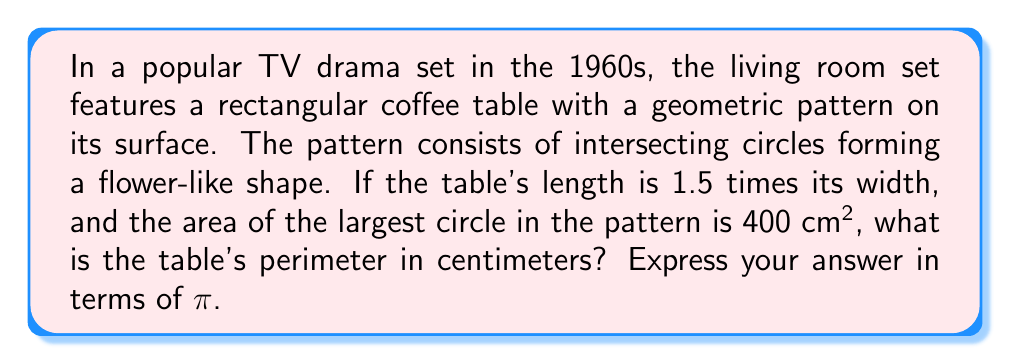Provide a solution to this math problem. Let's approach this step-by-step:

1) Let the width of the table be $w$ and the length be $l$. We know that $l = 1.5w$.

2) The area of the largest circle is 400 cm². Let's call the radius of this circle $r$. We can write:

   $$πr^2 = 400$$

3) Solving for $r$:
   
   $$r^2 = \frac{400}{π}$$
   $$r = \sqrt{\frac{400}{π}} = \frac{20}{\sqrt{π}}$$

4) The diameter of this circle would be the width of the table. So:

   $$w = 2r = \frac{40}{\sqrt{π}}$$

5) Now we can find the length:

   $$l = 1.5w = 1.5 \cdot \frac{40}{\sqrt{π}} = \frac{60}{\sqrt{π}}$$

6) The perimeter of a rectangle is given by $2l + 2w$. So:

   $$\text{Perimeter} = 2 \cdot \frac{60}{\sqrt{π}} + 2 \cdot \frac{40}{\sqrt{π}}$$
   $$= \frac{120}{\sqrt{π}} + \frac{80}{\sqrt{π}}$$
   $$= \frac{200}{\sqrt{π}}$$

7) Simplify:
   
   $$\frac{200}{\sqrt{π}} = \frac{200\sqrt{π}}{π} = \frac{200\sqrt{π}}{π} \cdot \frac{\sqrt{π}}{\sqrt{π}} = \frac{200π}{\sqrt{π^3}}$$

Therefore, the perimeter of the table is $\frac{200π}{\sqrt{π^3}}$ cm.
Answer: $\frac{200π}{\sqrt{π^3}}$ cm 